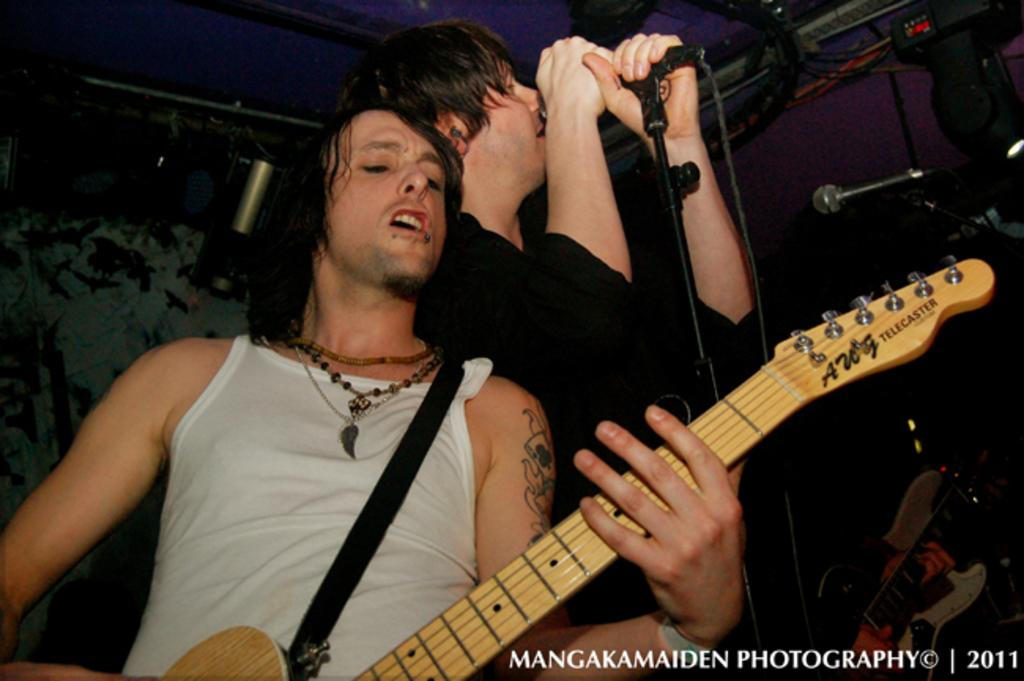What is the person wearing white doing in the image? The person wearing white is playing a guitar. What is the person wearing black doing in the image? The person wearing black is singing. Can you describe the position of the person wearing black in relation to the microphone? The person wearing black is in front of a microphone. What type of shoe is being sold in the image? There is no shoe being sold in the image; it features two people, one playing a guitar and the other singing in front of a microphone. What channel is broadcasting the performance in the image? There is no channel broadcasting the performance in the image; it is a still image of two people playing music. 